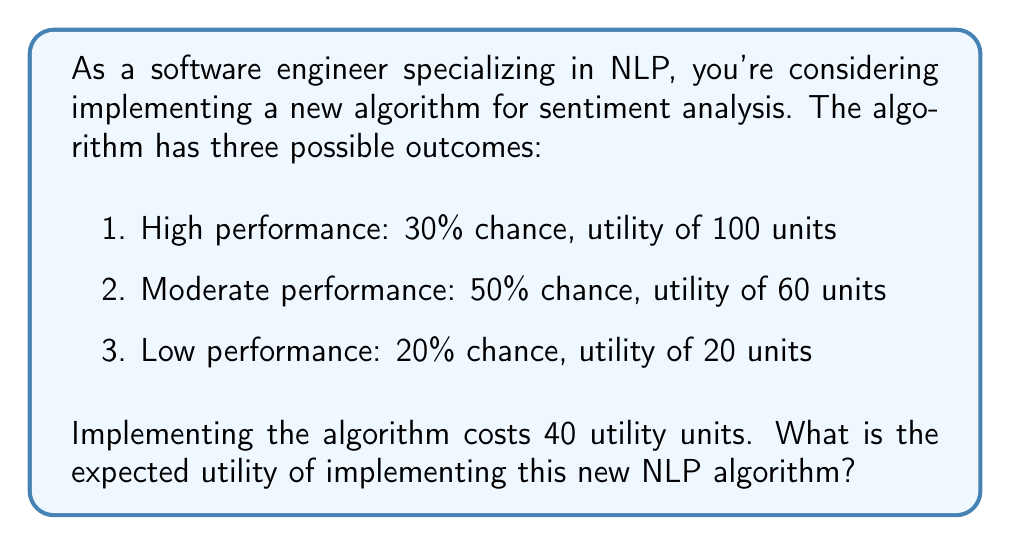Provide a solution to this math problem. To solve this problem, we need to follow these steps:

1. Calculate the expected utility of the algorithm's performance:
   Let's use the formula for expected value:
   $$E(X) = \sum_{i=1}^{n} p_i \cdot x_i$$
   Where $p_i$ is the probability of each outcome and $x_i$ is the utility of each outcome.

   $$E(X) = (0.30 \cdot 100) + (0.50 \cdot 60) + (0.20 \cdot 20)$$
   $$E(X) = 30 + 30 + 4 = 64$$

2. Subtract the implementation cost:
   The net expected utility is the expected utility minus the implementation cost.
   $$\text{Net Expected Utility} = E(X) - \text{Implementation Cost}$$
   $$\text{Net Expected Utility} = 64 - 40 = 24$$

Therefore, the expected utility of implementing the new NLP algorithm is 24 units.
Answer: The expected utility of implementing the new NLP algorithm is 24 units. 